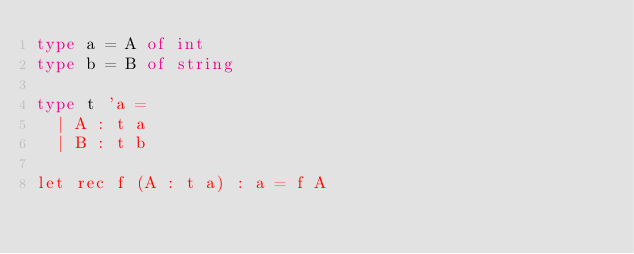<code> <loc_0><loc_0><loc_500><loc_500><_OCaml_>type a = A of int
type b = B of string

type t 'a =
  | A : t a
  | B : t b

let rec f (A : t a) : a = f A
</code> 